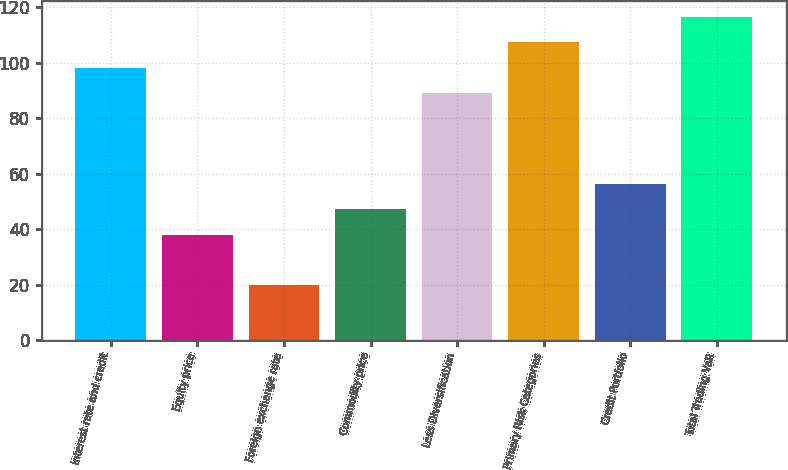Convert chart to OTSL. <chart><loc_0><loc_0><loc_500><loc_500><bar_chart><fcel>Interest rate and credit<fcel>Equity price<fcel>Foreign exchange rate<fcel>Commodity price<fcel>Less Diversification<fcel>Primary Risk Categories<fcel>Credit Portfolio<fcel>Total Trading VaR<nl><fcel>98.2<fcel>38<fcel>20<fcel>47.2<fcel>89<fcel>107.4<fcel>56.4<fcel>116.6<nl></chart> 